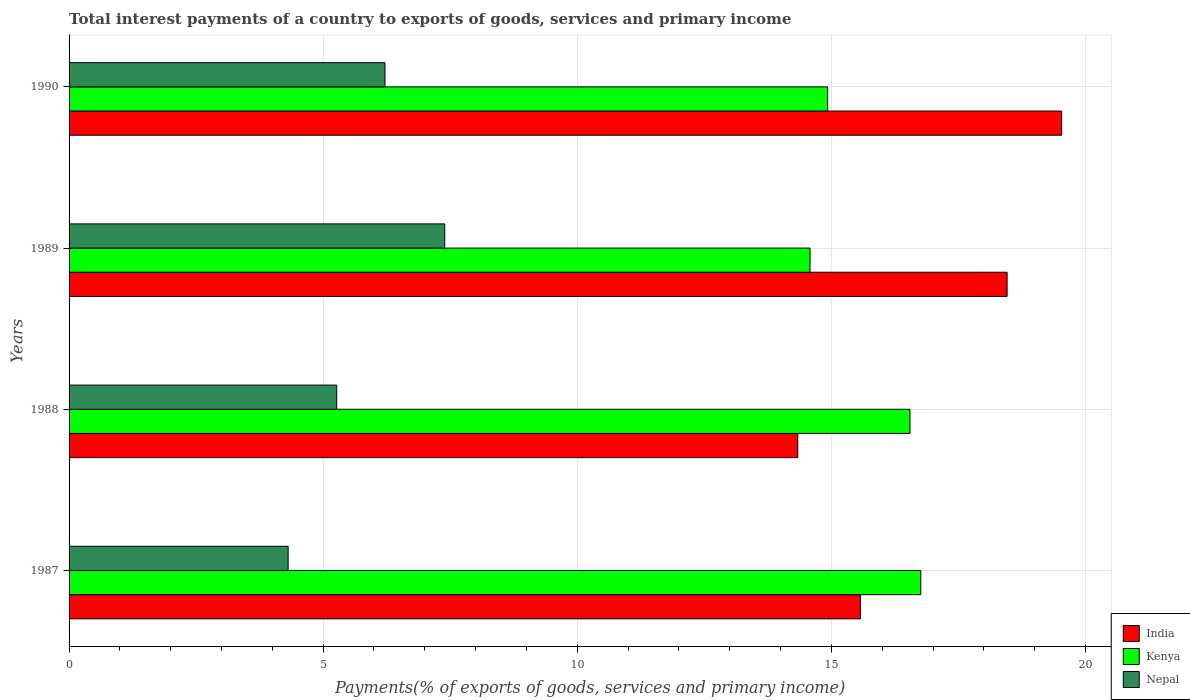How many groups of bars are there?
Your answer should be very brief. 4. Are the number of bars per tick equal to the number of legend labels?
Keep it short and to the point. Yes. What is the label of the 1st group of bars from the top?
Provide a succinct answer. 1990. In how many cases, is the number of bars for a given year not equal to the number of legend labels?
Offer a very short reply. 0. What is the total interest payments in Nepal in 1990?
Provide a succinct answer. 6.22. Across all years, what is the maximum total interest payments in Nepal?
Your response must be concise. 7.39. Across all years, what is the minimum total interest payments in Kenya?
Ensure brevity in your answer.  14.58. In which year was the total interest payments in Nepal maximum?
Your response must be concise. 1989. In which year was the total interest payments in India minimum?
Ensure brevity in your answer.  1988. What is the total total interest payments in India in the graph?
Keep it short and to the point. 67.9. What is the difference between the total interest payments in India in 1989 and that in 1990?
Offer a very short reply. -1.07. What is the difference between the total interest payments in Nepal in 1990 and the total interest payments in Kenya in 1987?
Offer a very short reply. -10.54. What is the average total interest payments in Kenya per year?
Offer a very short reply. 15.7. In the year 1990, what is the difference between the total interest payments in Nepal and total interest payments in India?
Keep it short and to the point. -13.31. In how many years, is the total interest payments in India greater than 9 %?
Your answer should be compact. 4. What is the ratio of the total interest payments in India in 1987 to that in 1988?
Give a very brief answer. 1.09. Is the total interest payments in Nepal in 1987 less than that in 1990?
Your answer should be compact. Yes. What is the difference between the highest and the second highest total interest payments in Kenya?
Make the answer very short. 0.21. What is the difference between the highest and the lowest total interest payments in India?
Provide a succinct answer. 5.19. In how many years, is the total interest payments in India greater than the average total interest payments in India taken over all years?
Provide a succinct answer. 2. Is the sum of the total interest payments in Kenya in 1989 and 1990 greater than the maximum total interest payments in India across all years?
Offer a very short reply. Yes. What does the 2nd bar from the top in 1989 represents?
Provide a succinct answer. Kenya. What does the 1st bar from the bottom in 1989 represents?
Offer a very short reply. India. How many bars are there?
Your answer should be compact. 12. Are all the bars in the graph horizontal?
Your answer should be very brief. Yes. How many years are there in the graph?
Provide a succinct answer. 4. Are the values on the major ticks of X-axis written in scientific E-notation?
Provide a short and direct response. No. Does the graph contain grids?
Provide a short and direct response. Yes. How many legend labels are there?
Your response must be concise. 3. How are the legend labels stacked?
Provide a succinct answer. Vertical. What is the title of the graph?
Make the answer very short. Total interest payments of a country to exports of goods, services and primary income. Does "Arab World" appear as one of the legend labels in the graph?
Keep it short and to the point. No. What is the label or title of the X-axis?
Provide a short and direct response. Payments(% of exports of goods, services and primary income). What is the label or title of the Y-axis?
Offer a terse response. Years. What is the Payments(% of exports of goods, services and primary income) in India in 1987?
Provide a succinct answer. 15.57. What is the Payments(% of exports of goods, services and primary income) in Kenya in 1987?
Provide a short and direct response. 16.76. What is the Payments(% of exports of goods, services and primary income) in Nepal in 1987?
Provide a succinct answer. 4.31. What is the Payments(% of exports of goods, services and primary income) in India in 1988?
Provide a short and direct response. 14.34. What is the Payments(% of exports of goods, services and primary income) in Kenya in 1988?
Provide a short and direct response. 16.55. What is the Payments(% of exports of goods, services and primary income) in Nepal in 1988?
Give a very brief answer. 5.27. What is the Payments(% of exports of goods, services and primary income) of India in 1989?
Provide a succinct answer. 18.46. What is the Payments(% of exports of goods, services and primary income) in Kenya in 1989?
Your response must be concise. 14.58. What is the Payments(% of exports of goods, services and primary income) in Nepal in 1989?
Give a very brief answer. 7.39. What is the Payments(% of exports of goods, services and primary income) in India in 1990?
Your response must be concise. 19.53. What is the Payments(% of exports of goods, services and primary income) of Kenya in 1990?
Give a very brief answer. 14.93. What is the Payments(% of exports of goods, services and primary income) in Nepal in 1990?
Keep it short and to the point. 6.22. Across all years, what is the maximum Payments(% of exports of goods, services and primary income) in India?
Give a very brief answer. 19.53. Across all years, what is the maximum Payments(% of exports of goods, services and primary income) of Kenya?
Provide a short and direct response. 16.76. Across all years, what is the maximum Payments(% of exports of goods, services and primary income) of Nepal?
Offer a very short reply. 7.39. Across all years, what is the minimum Payments(% of exports of goods, services and primary income) of India?
Your response must be concise. 14.34. Across all years, what is the minimum Payments(% of exports of goods, services and primary income) of Kenya?
Provide a short and direct response. 14.58. Across all years, what is the minimum Payments(% of exports of goods, services and primary income) of Nepal?
Ensure brevity in your answer.  4.31. What is the total Payments(% of exports of goods, services and primary income) of India in the graph?
Ensure brevity in your answer.  67.9. What is the total Payments(% of exports of goods, services and primary income) in Kenya in the graph?
Offer a terse response. 62.81. What is the total Payments(% of exports of goods, services and primary income) in Nepal in the graph?
Make the answer very short. 23.19. What is the difference between the Payments(% of exports of goods, services and primary income) of India in 1987 and that in 1988?
Keep it short and to the point. 1.23. What is the difference between the Payments(% of exports of goods, services and primary income) of Kenya in 1987 and that in 1988?
Your answer should be very brief. 0.21. What is the difference between the Payments(% of exports of goods, services and primary income) in Nepal in 1987 and that in 1988?
Ensure brevity in your answer.  -0.96. What is the difference between the Payments(% of exports of goods, services and primary income) of India in 1987 and that in 1989?
Keep it short and to the point. -2.89. What is the difference between the Payments(% of exports of goods, services and primary income) of Kenya in 1987 and that in 1989?
Your answer should be compact. 2.18. What is the difference between the Payments(% of exports of goods, services and primary income) of Nepal in 1987 and that in 1989?
Provide a short and direct response. -3.08. What is the difference between the Payments(% of exports of goods, services and primary income) of India in 1987 and that in 1990?
Your answer should be very brief. -3.96. What is the difference between the Payments(% of exports of goods, services and primary income) in Kenya in 1987 and that in 1990?
Make the answer very short. 1.83. What is the difference between the Payments(% of exports of goods, services and primary income) of Nepal in 1987 and that in 1990?
Provide a succinct answer. -1.91. What is the difference between the Payments(% of exports of goods, services and primary income) of India in 1988 and that in 1989?
Provide a succinct answer. -4.12. What is the difference between the Payments(% of exports of goods, services and primary income) in Kenya in 1988 and that in 1989?
Offer a terse response. 1.97. What is the difference between the Payments(% of exports of goods, services and primary income) in Nepal in 1988 and that in 1989?
Offer a terse response. -2.13. What is the difference between the Payments(% of exports of goods, services and primary income) in India in 1988 and that in 1990?
Make the answer very short. -5.19. What is the difference between the Payments(% of exports of goods, services and primary income) in Kenya in 1988 and that in 1990?
Offer a terse response. 1.62. What is the difference between the Payments(% of exports of goods, services and primary income) in Nepal in 1988 and that in 1990?
Your answer should be very brief. -0.95. What is the difference between the Payments(% of exports of goods, services and primary income) in India in 1989 and that in 1990?
Offer a very short reply. -1.07. What is the difference between the Payments(% of exports of goods, services and primary income) in Kenya in 1989 and that in 1990?
Your response must be concise. -0.35. What is the difference between the Payments(% of exports of goods, services and primary income) of Nepal in 1989 and that in 1990?
Give a very brief answer. 1.18. What is the difference between the Payments(% of exports of goods, services and primary income) in India in 1987 and the Payments(% of exports of goods, services and primary income) in Kenya in 1988?
Offer a terse response. -0.97. What is the difference between the Payments(% of exports of goods, services and primary income) in India in 1987 and the Payments(% of exports of goods, services and primary income) in Nepal in 1988?
Your response must be concise. 10.31. What is the difference between the Payments(% of exports of goods, services and primary income) of Kenya in 1987 and the Payments(% of exports of goods, services and primary income) of Nepal in 1988?
Make the answer very short. 11.49. What is the difference between the Payments(% of exports of goods, services and primary income) of India in 1987 and the Payments(% of exports of goods, services and primary income) of Nepal in 1989?
Give a very brief answer. 8.18. What is the difference between the Payments(% of exports of goods, services and primary income) in Kenya in 1987 and the Payments(% of exports of goods, services and primary income) in Nepal in 1989?
Your response must be concise. 9.37. What is the difference between the Payments(% of exports of goods, services and primary income) of India in 1987 and the Payments(% of exports of goods, services and primary income) of Kenya in 1990?
Make the answer very short. 0.65. What is the difference between the Payments(% of exports of goods, services and primary income) in India in 1987 and the Payments(% of exports of goods, services and primary income) in Nepal in 1990?
Your answer should be very brief. 9.36. What is the difference between the Payments(% of exports of goods, services and primary income) of Kenya in 1987 and the Payments(% of exports of goods, services and primary income) of Nepal in 1990?
Offer a terse response. 10.54. What is the difference between the Payments(% of exports of goods, services and primary income) of India in 1988 and the Payments(% of exports of goods, services and primary income) of Kenya in 1989?
Offer a very short reply. -0.24. What is the difference between the Payments(% of exports of goods, services and primary income) in India in 1988 and the Payments(% of exports of goods, services and primary income) in Nepal in 1989?
Give a very brief answer. 6.95. What is the difference between the Payments(% of exports of goods, services and primary income) in Kenya in 1988 and the Payments(% of exports of goods, services and primary income) in Nepal in 1989?
Ensure brevity in your answer.  9.15. What is the difference between the Payments(% of exports of goods, services and primary income) in India in 1988 and the Payments(% of exports of goods, services and primary income) in Kenya in 1990?
Offer a terse response. -0.59. What is the difference between the Payments(% of exports of goods, services and primary income) of India in 1988 and the Payments(% of exports of goods, services and primary income) of Nepal in 1990?
Offer a terse response. 8.12. What is the difference between the Payments(% of exports of goods, services and primary income) of Kenya in 1988 and the Payments(% of exports of goods, services and primary income) of Nepal in 1990?
Provide a succinct answer. 10.33. What is the difference between the Payments(% of exports of goods, services and primary income) of India in 1989 and the Payments(% of exports of goods, services and primary income) of Kenya in 1990?
Provide a short and direct response. 3.53. What is the difference between the Payments(% of exports of goods, services and primary income) in India in 1989 and the Payments(% of exports of goods, services and primary income) in Nepal in 1990?
Provide a succinct answer. 12.24. What is the difference between the Payments(% of exports of goods, services and primary income) of Kenya in 1989 and the Payments(% of exports of goods, services and primary income) of Nepal in 1990?
Offer a very short reply. 8.36. What is the average Payments(% of exports of goods, services and primary income) of India per year?
Offer a terse response. 16.97. What is the average Payments(% of exports of goods, services and primary income) of Kenya per year?
Make the answer very short. 15.7. What is the average Payments(% of exports of goods, services and primary income) of Nepal per year?
Ensure brevity in your answer.  5.8. In the year 1987, what is the difference between the Payments(% of exports of goods, services and primary income) in India and Payments(% of exports of goods, services and primary income) in Kenya?
Keep it short and to the point. -1.19. In the year 1987, what is the difference between the Payments(% of exports of goods, services and primary income) of India and Payments(% of exports of goods, services and primary income) of Nepal?
Make the answer very short. 11.26. In the year 1987, what is the difference between the Payments(% of exports of goods, services and primary income) of Kenya and Payments(% of exports of goods, services and primary income) of Nepal?
Your answer should be compact. 12.45. In the year 1988, what is the difference between the Payments(% of exports of goods, services and primary income) in India and Payments(% of exports of goods, services and primary income) in Kenya?
Offer a terse response. -2.21. In the year 1988, what is the difference between the Payments(% of exports of goods, services and primary income) in India and Payments(% of exports of goods, services and primary income) in Nepal?
Offer a terse response. 9.07. In the year 1988, what is the difference between the Payments(% of exports of goods, services and primary income) in Kenya and Payments(% of exports of goods, services and primary income) in Nepal?
Provide a succinct answer. 11.28. In the year 1989, what is the difference between the Payments(% of exports of goods, services and primary income) of India and Payments(% of exports of goods, services and primary income) of Kenya?
Your answer should be compact. 3.88. In the year 1989, what is the difference between the Payments(% of exports of goods, services and primary income) of India and Payments(% of exports of goods, services and primary income) of Nepal?
Ensure brevity in your answer.  11.07. In the year 1989, what is the difference between the Payments(% of exports of goods, services and primary income) of Kenya and Payments(% of exports of goods, services and primary income) of Nepal?
Your answer should be compact. 7.19. In the year 1990, what is the difference between the Payments(% of exports of goods, services and primary income) of India and Payments(% of exports of goods, services and primary income) of Kenya?
Offer a terse response. 4.6. In the year 1990, what is the difference between the Payments(% of exports of goods, services and primary income) in India and Payments(% of exports of goods, services and primary income) in Nepal?
Offer a terse response. 13.31. In the year 1990, what is the difference between the Payments(% of exports of goods, services and primary income) in Kenya and Payments(% of exports of goods, services and primary income) in Nepal?
Give a very brief answer. 8.71. What is the ratio of the Payments(% of exports of goods, services and primary income) in India in 1987 to that in 1988?
Your answer should be compact. 1.09. What is the ratio of the Payments(% of exports of goods, services and primary income) in Kenya in 1987 to that in 1988?
Keep it short and to the point. 1.01. What is the ratio of the Payments(% of exports of goods, services and primary income) of Nepal in 1987 to that in 1988?
Make the answer very short. 0.82. What is the ratio of the Payments(% of exports of goods, services and primary income) of India in 1987 to that in 1989?
Offer a terse response. 0.84. What is the ratio of the Payments(% of exports of goods, services and primary income) of Kenya in 1987 to that in 1989?
Provide a succinct answer. 1.15. What is the ratio of the Payments(% of exports of goods, services and primary income) of Nepal in 1987 to that in 1989?
Provide a succinct answer. 0.58. What is the ratio of the Payments(% of exports of goods, services and primary income) of India in 1987 to that in 1990?
Make the answer very short. 0.8. What is the ratio of the Payments(% of exports of goods, services and primary income) of Kenya in 1987 to that in 1990?
Your answer should be compact. 1.12. What is the ratio of the Payments(% of exports of goods, services and primary income) in Nepal in 1987 to that in 1990?
Offer a very short reply. 0.69. What is the ratio of the Payments(% of exports of goods, services and primary income) of India in 1988 to that in 1989?
Give a very brief answer. 0.78. What is the ratio of the Payments(% of exports of goods, services and primary income) in Kenya in 1988 to that in 1989?
Provide a short and direct response. 1.13. What is the ratio of the Payments(% of exports of goods, services and primary income) in Nepal in 1988 to that in 1989?
Make the answer very short. 0.71. What is the ratio of the Payments(% of exports of goods, services and primary income) in India in 1988 to that in 1990?
Your answer should be very brief. 0.73. What is the ratio of the Payments(% of exports of goods, services and primary income) in Kenya in 1988 to that in 1990?
Offer a terse response. 1.11. What is the ratio of the Payments(% of exports of goods, services and primary income) in Nepal in 1988 to that in 1990?
Your answer should be compact. 0.85. What is the ratio of the Payments(% of exports of goods, services and primary income) of India in 1989 to that in 1990?
Keep it short and to the point. 0.95. What is the ratio of the Payments(% of exports of goods, services and primary income) in Kenya in 1989 to that in 1990?
Give a very brief answer. 0.98. What is the ratio of the Payments(% of exports of goods, services and primary income) in Nepal in 1989 to that in 1990?
Make the answer very short. 1.19. What is the difference between the highest and the second highest Payments(% of exports of goods, services and primary income) in India?
Offer a very short reply. 1.07. What is the difference between the highest and the second highest Payments(% of exports of goods, services and primary income) in Kenya?
Offer a very short reply. 0.21. What is the difference between the highest and the second highest Payments(% of exports of goods, services and primary income) in Nepal?
Your response must be concise. 1.18. What is the difference between the highest and the lowest Payments(% of exports of goods, services and primary income) in India?
Keep it short and to the point. 5.19. What is the difference between the highest and the lowest Payments(% of exports of goods, services and primary income) of Kenya?
Make the answer very short. 2.18. What is the difference between the highest and the lowest Payments(% of exports of goods, services and primary income) of Nepal?
Ensure brevity in your answer.  3.08. 